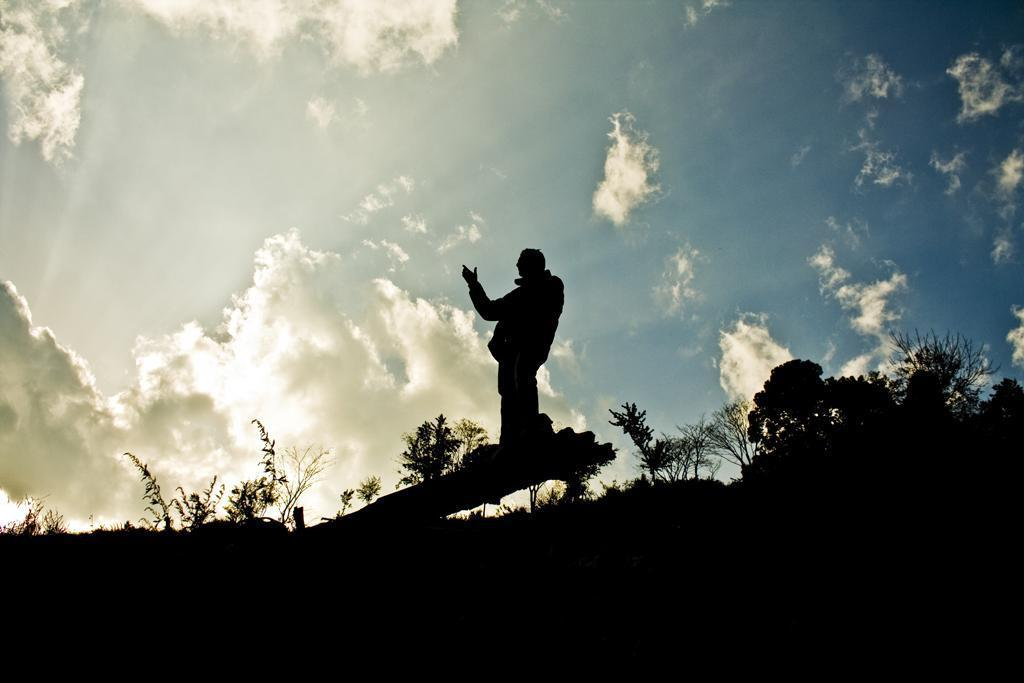Where was the image taken? The image was clicked outside. What type of vegetation can be seen in the image? There are trees and plants in the image. Can you describe the person in the image? There is a person standing in the middle of the image. What is visible at the top of the image? The sky is visible at the top of the image. What type of pin is the person wearing on their shirt in the image? There is no pin visible on the person's shirt in the image. What is the reason for the protest happening in the image? There is no protest present in the image. 